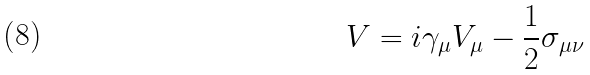Convert formula to latex. <formula><loc_0><loc_0><loc_500><loc_500>V = i \gamma _ { \mu } V _ { \mu } - \frac { 1 } { 2 } \sigma _ { \mu \nu }</formula> 